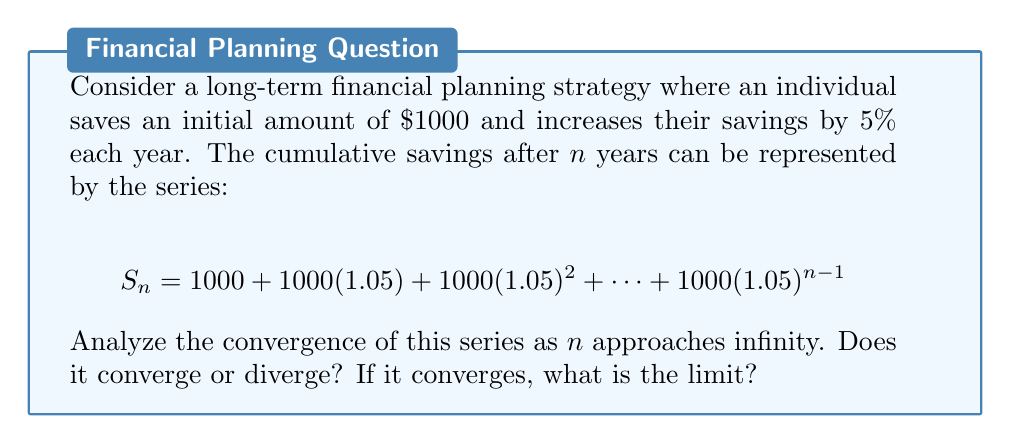What is the answer to this math problem? To analyze the convergence of this series, we'll follow these steps:

1) First, recognize that this is a geometric series with:
   - First term: $a = 1000$
   - Common ratio: $r = 1.05$

2) The general formula for the sum of a geometric series with n terms is:
   $$S_n = a\frac{1-r^n}{1-r}$$

3) For our series:
   $$S_n = 1000\frac{1-(1.05)^n}{1-1.05}$$

4) Simplify:
   $$S_n = 1000\frac{1-(1.05)^n}{-0.05} = 20000(1-(1.05)^n)$$

5) To determine convergence as n approaches infinity, we need to evaluate:
   $$\lim_{n\to\infty} S_n = \lim_{n\to\infty} 20000(1-(1.05)^n)$$

6) As n approaches infinity, $(1.05)^n$ grows without bound because 1.05 > 1.

7) Therefore:
   $$\lim_{n\to\infty} S_n = \lim_{n\to\infty} 20000(1-(1.05)^n) = -\infty$$

8) Since the limit doesn't exist (it tends to negative infinity), the series diverges.

This result aligns with the financial interpretation: with consistent savings and compound growth, the cumulative savings will continue to grow without bound over time.
Answer: The series diverges as $n$ approaches infinity. 